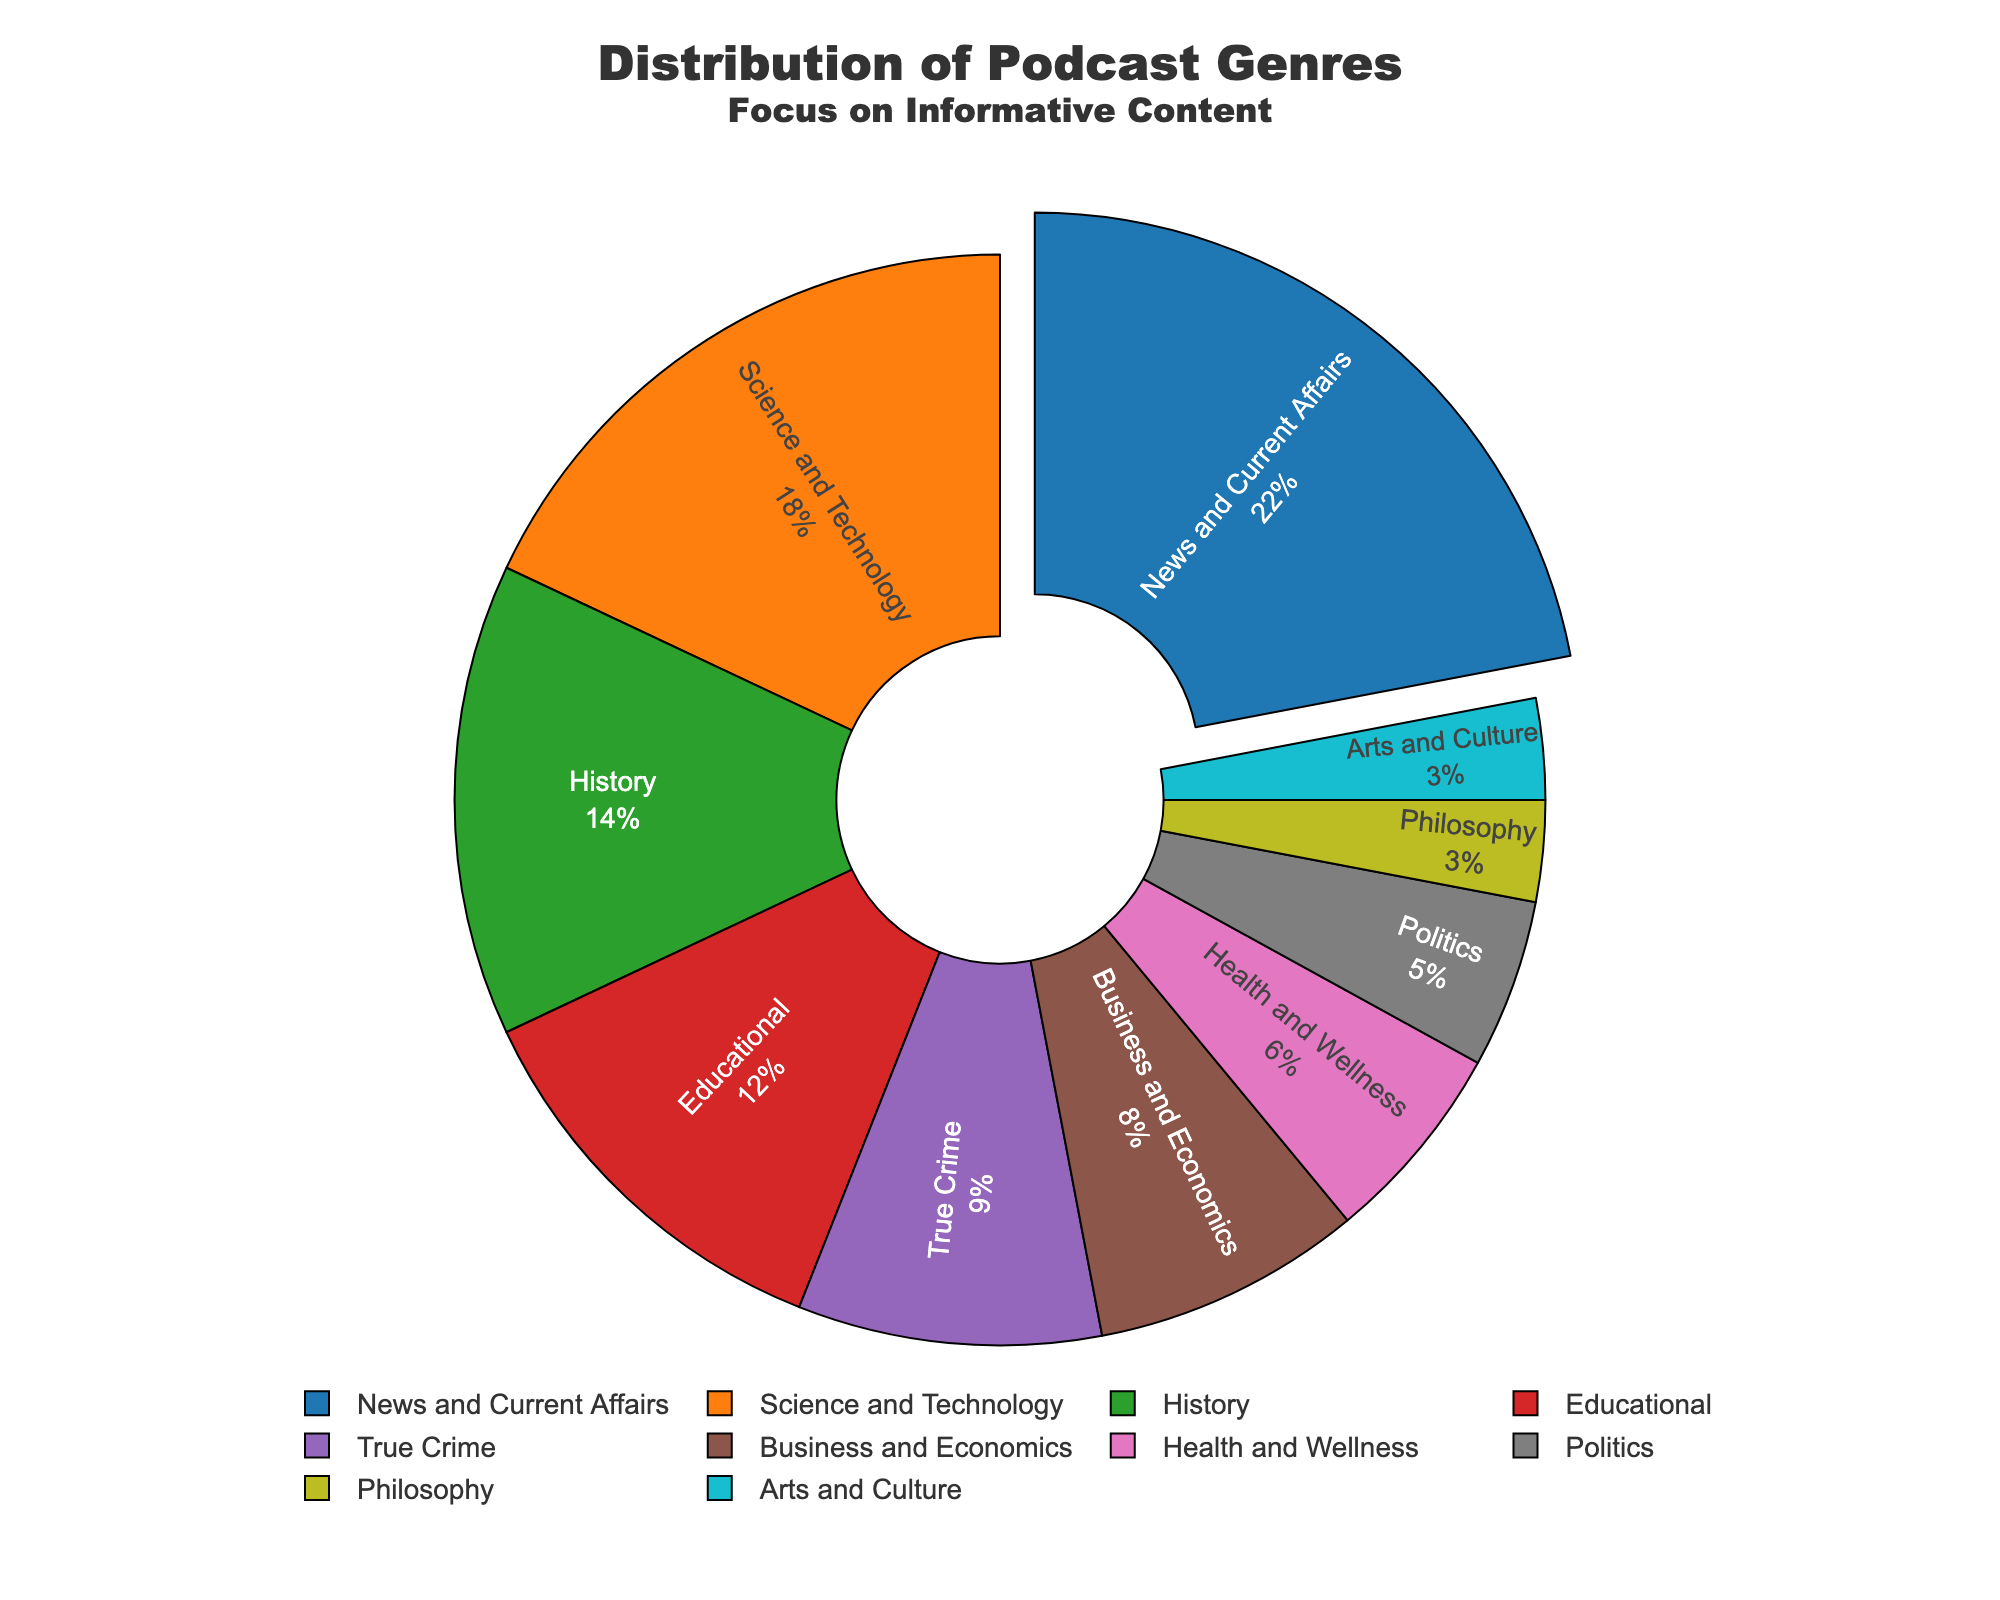What percentage of podcasts focus on educational content? The pie chart shows the different genres of podcasts and their corresponding percentages. The slice labeled "Educational" indicates a percentage of 12%.
Answer: 12% How does the percentage of Science and Technology podcasts compare to Health and Wellness podcasts? The percentage of Science and Technology podcasts is 18%, and Health and Wellness podcasts is 6%. Comparing these, Science and Technology has a higher percentage than Health and Wellness.
Answer: Science and Technology > Health and Wellness What is the combined percentage for News and Current Affairs, and History? The slice for News and Current Affairs shows 22%, and History shows 14%. Adding these two percentages gives: 22% + 14% = 36%.
Answer: 36% Which genre has the largest representation in the chart and what is its percentage? The largest slice in the pie chart is labeled "News and Current Affairs" with a percentage of 22%.
Answer: News and Current Affairs with 22% What genres have a percentage less than 10%? The genres True Crime (9%), Business and Economics (8%), Health and Wellness (6%), Politics (5%), Philosophy (3%), and Arts and Culture (3%) all have percentages less than 10%.
Answer: True Crime, Business and Economics, Health and Wellness, Politics, Philosophy, Arts and Culture What is the difference in percentage between Business and Economics and Philosophy? The slice for Business and Economics shows 8%, and Philosophy shows 3%. The difference is calculated as follows: 8% - 3% = 5%.
Answer: 5% Which two genres combined have the exact same percentage as News and Current Affairs? The percentage for News and Current Affairs is 22%. The genres Science and Technology (18%) and Philosophy (3%) together yield: 18% + 3% = 21%, which doesn't match. Let's try another pair: History (14%) and Educational (12%) yield: 14% + 12% = 26%, which is also not exact. The correct combination is not found; hence, no exact matches.
Answer: No exact matches What is the total percentage of podcasts categorized under informative content? Informative content genres include News and Current Affairs (22%), Science and Technology (18%), History (14%), and Educational (12%). Adding these gives: 22% + 18% + 14% + 12% = 66%.
Answer: 66% Considering the provided genres, which genre represents the minimum percentage and what is it? The smallest slice in the pie chart is labeled "Philosophy" with a percentage of 3%.
Answer: Philosophy with 3% Which genre of podcasts occupies the third largest percentage? The third largest slice in the pie chart corresponds to the History genre with 14%.
Answer: History with 14% Comparing News and Current Affairs to all other genres combined, which is larger and by how much? News and Current Affairs has 22%. Summing the other genres: 78%. The difference is 78% - 22% = 56%. Other genres combined are larger by 56%.
Answer: Other genres by 56% 